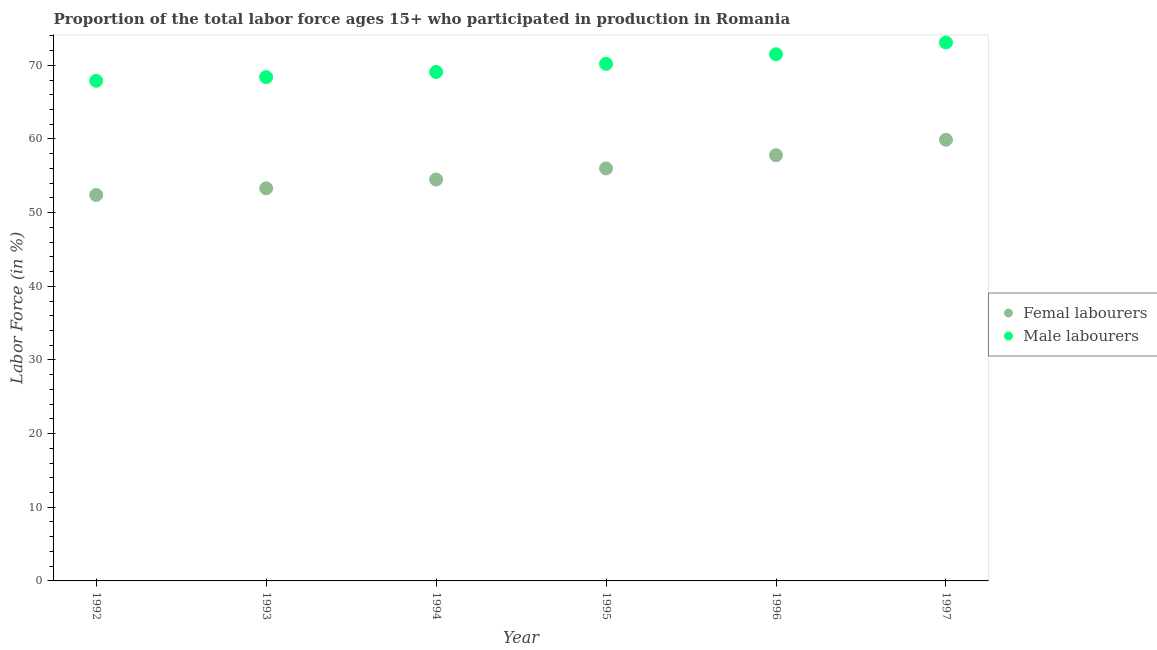What is the percentage of male labour force in 1992?
Your answer should be very brief. 67.9. Across all years, what is the maximum percentage of female labor force?
Your answer should be compact. 59.9. Across all years, what is the minimum percentage of male labour force?
Your answer should be very brief. 67.9. In which year was the percentage of male labour force maximum?
Provide a succinct answer. 1997. What is the total percentage of male labour force in the graph?
Offer a terse response. 420.2. What is the difference between the percentage of female labor force in 1996 and that in 1997?
Offer a terse response. -2.1. What is the difference between the percentage of male labour force in 1997 and the percentage of female labor force in 1993?
Offer a terse response. 19.8. What is the average percentage of female labor force per year?
Your answer should be very brief. 55.65. In the year 1996, what is the difference between the percentage of female labor force and percentage of male labour force?
Offer a very short reply. -13.7. What is the ratio of the percentage of male labour force in 1995 to that in 1996?
Your answer should be very brief. 0.98. What is the difference between the highest and the second highest percentage of female labor force?
Your response must be concise. 2.1. What is the difference between the highest and the lowest percentage of male labour force?
Your answer should be very brief. 5.2. In how many years, is the percentage of female labor force greater than the average percentage of female labor force taken over all years?
Ensure brevity in your answer.  3. Does the percentage of female labor force monotonically increase over the years?
Ensure brevity in your answer.  Yes. Is the percentage of male labour force strictly greater than the percentage of female labor force over the years?
Offer a terse response. Yes. Is the percentage of female labor force strictly less than the percentage of male labour force over the years?
Provide a short and direct response. Yes. What is the difference between two consecutive major ticks on the Y-axis?
Provide a succinct answer. 10. Does the graph contain any zero values?
Keep it short and to the point. No. Does the graph contain grids?
Give a very brief answer. No. Where does the legend appear in the graph?
Offer a terse response. Center right. How many legend labels are there?
Your answer should be very brief. 2. How are the legend labels stacked?
Make the answer very short. Vertical. What is the title of the graph?
Your answer should be very brief. Proportion of the total labor force ages 15+ who participated in production in Romania. What is the Labor Force (in %) in Femal labourers in 1992?
Your response must be concise. 52.4. What is the Labor Force (in %) of Male labourers in 1992?
Your answer should be very brief. 67.9. What is the Labor Force (in %) of Femal labourers in 1993?
Your answer should be compact. 53.3. What is the Labor Force (in %) in Male labourers in 1993?
Ensure brevity in your answer.  68.4. What is the Labor Force (in %) in Femal labourers in 1994?
Offer a very short reply. 54.5. What is the Labor Force (in %) of Male labourers in 1994?
Offer a very short reply. 69.1. What is the Labor Force (in %) in Male labourers in 1995?
Your answer should be compact. 70.2. What is the Labor Force (in %) of Femal labourers in 1996?
Your answer should be very brief. 57.8. What is the Labor Force (in %) of Male labourers in 1996?
Your answer should be very brief. 71.5. What is the Labor Force (in %) in Femal labourers in 1997?
Your answer should be very brief. 59.9. What is the Labor Force (in %) in Male labourers in 1997?
Your answer should be compact. 73.1. Across all years, what is the maximum Labor Force (in %) in Femal labourers?
Your response must be concise. 59.9. Across all years, what is the maximum Labor Force (in %) of Male labourers?
Your response must be concise. 73.1. Across all years, what is the minimum Labor Force (in %) in Femal labourers?
Give a very brief answer. 52.4. Across all years, what is the minimum Labor Force (in %) of Male labourers?
Offer a terse response. 67.9. What is the total Labor Force (in %) in Femal labourers in the graph?
Provide a succinct answer. 333.9. What is the total Labor Force (in %) in Male labourers in the graph?
Ensure brevity in your answer.  420.2. What is the difference between the Labor Force (in %) of Femal labourers in 1992 and that in 1993?
Provide a short and direct response. -0.9. What is the difference between the Labor Force (in %) of Male labourers in 1992 and that in 1994?
Your answer should be very brief. -1.2. What is the difference between the Labor Force (in %) in Femal labourers in 1992 and that in 1996?
Give a very brief answer. -5.4. What is the difference between the Labor Force (in %) of Male labourers in 1992 and that in 1996?
Provide a short and direct response. -3.6. What is the difference between the Labor Force (in %) of Male labourers in 1992 and that in 1997?
Provide a succinct answer. -5.2. What is the difference between the Labor Force (in %) in Femal labourers in 1993 and that in 1994?
Keep it short and to the point. -1.2. What is the difference between the Labor Force (in %) of Male labourers in 1993 and that in 1994?
Provide a short and direct response. -0.7. What is the difference between the Labor Force (in %) in Femal labourers in 1993 and that in 1995?
Provide a short and direct response. -2.7. What is the difference between the Labor Force (in %) in Male labourers in 1993 and that in 1995?
Provide a short and direct response. -1.8. What is the difference between the Labor Force (in %) in Femal labourers in 1993 and that in 1996?
Your answer should be very brief. -4.5. What is the difference between the Labor Force (in %) of Femal labourers in 1994 and that in 1995?
Provide a succinct answer. -1.5. What is the difference between the Labor Force (in %) in Male labourers in 1994 and that in 1995?
Your answer should be very brief. -1.1. What is the difference between the Labor Force (in %) of Male labourers in 1994 and that in 1997?
Your answer should be very brief. -4. What is the difference between the Labor Force (in %) of Male labourers in 1995 and that in 1996?
Offer a very short reply. -1.3. What is the difference between the Labor Force (in %) of Femal labourers in 1995 and that in 1997?
Keep it short and to the point. -3.9. What is the difference between the Labor Force (in %) of Femal labourers in 1992 and the Labor Force (in %) of Male labourers in 1994?
Ensure brevity in your answer.  -16.7. What is the difference between the Labor Force (in %) of Femal labourers in 1992 and the Labor Force (in %) of Male labourers in 1995?
Ensure brevity in your answer.  -17.8. What is the difference between the Labor Force (in %) in Femal labourers in 1992 and the Labor Force (in %) in Male labourers in 1996?
Your answer should be compact. -19.1. What is the difference between the Labor Force (in %) in Femal labourers in 1992 and the Labor Force (in %) in Male labourers in 1997?
Provide a short and direct response. -20.7. What is the difference between the Labor Force (in %) of Femal labourers in 1993 and the Labor Force (in %) of Male labourers in 1994?
Your answer should be very brief. -15.8. What is the difference between the Labor Force (in %) in Femal labourers in 1993 and the Labor Force (in %) in Male labourers in 1995?
Offer a very short reply. -16.9. What is the difference between the Labor Force (in %) of Femal labourers in 1993 and the Labor Force (in %) of Male labourers in 1996?
Your answer should be very brief. -18.2. What is the difference between the Labor Force (in %) of Femal labourers in 1993 and the Labor Force (in %) of Male labourers in 1997?
Ensure brevity in your answer.  -19.8. What is the difference between the Labor Force (in %) of Femal labourers in 1994 and the Labor Force (in %) of Male labourers in 1995?
Your answer should be compact. -15.7. What is the difference between the Labor Force (in %) in Femal labourers in 1994 and the Labor Force (in %) in Male labourers in 1996?
Provide a succinct answer. -17. What is the difference between the Labor Force (in %) of Femal labourers in 1994 and the Labor Force (in %) of Male labourers in 1997?
Provide a short and direct response. -18.6. What is the difference between the Labor Force (in %) in Femal labourers in 1995 and the Labor Force (in %) in Male labourers in 1996?
Your response must be concise. -15.5. What is the difference between the Labor Force (in %) in Femal labourers in 1995 and the Labor Force (in %) in Male labourers in 1997?
Give a very brief answer. -17.1. What is the difference between the Labor Force (in %) in Femal labourers in 1996 and the Labor Force (in %) in Male labourers in 1997?
Provide a succinct answer. -15.3. What is the average Labor Force (in %) of Femal labourers per year?
Ensure brevity in your answer.  55.65. What is the average Labor Force (in %) in Male labourers per year?
Your answer should be very brief. 70.03. In the year 1992, what is the difference between the Labor Force (in %) of Femal labourers and Labor Force (in %) of Male labourers?
Provide a short and direct response. -15.5. In the year 1993, what is the difference between the Labor Force (in %) in Femal labourers and Labor Force (in %) in Male labourers?
Your response must be concise. -15.1. In the year 1994, what is the difference between the Labor Force (in %) in Femal labourers and Labor Force (in %) in Male labourers?
Ensure brevity in your answer.  -14.6. In the year 1996, what is the difference between the Labor Force (in %) in Femal labourers and Labor Force (in %) in Male labourers?
Offer a very short reply. -13.7. What is the ratio of the Labor Force (in %) of Femal labourers in 1992 to that in 1993?
Make the answer very short. 0.98. What is the ratio of the Labor Force (in %) in Male labourers in 1992 to that in 1993?
Your answer should be compact. 0.99. What is the ratio of the Labor Force (in %) in Femal labourers in 1992 to that in 1994?
Your answer should be very brief. 0.96. What is the ratio of the Labor Force (in %) in Male labourers in 1992 to that in 1994?
Provide a succinct answer. 0.98. What is the ratio of the Labor Force (in %) in Femal labourers in 1992 to that in 1995?
Keep it short and to the point. 0.94. What is the ratio of the Labor Force (in %) in Male labourers in 1992 to that in 1995?
Ensure brevity in your answer.  0.97. What is the ratio of the Labor Force (in %) of Femal labourers in 1992 to that in 1996?
Your answer should be very brief. 0.91. What is the ratio of the Labor Force (in %) in Male labourers in 1992 to that in 1996?
Offer a terse response. 0.95. What is the ratio of the Labor Force (in %) of Femal labourers in 1992 to that in 1997?
Provide a short and direct response. 0.87. What is the ratio of the Labor Force (in %) in Male labourers in 1992 to that in 1997?
Provide a succinct answer. 0.93. What is the ratio of the Labor Force (in %) of Femal labourers in 1993 to that in 1994?
Your response must be concise. 0.98. What is the ratio of the Labor Force (in %) of Femal labourers in 1993 to that in 1995?
Keep it short and to the point. 0.95. What is the ratio of the Labor Force (in %) in Male labourers in 1993 to that in 1995?
Offer a terse response. 0.97. What is the ratio of the Labor Force (in %) in Femal labourers in 1993 to that in 1996?
Provide a succinct answer. 0.92. What is the ratio of the Labor Force (in %) in Male labourers in 1993 to that in 1996?
Provide a succinct answer. 0.96. What is the ratio of the Labor Force (in %) in Femal labourers in 1993 to that in 1997?
Offer a terse response. 0.89. What is the ratio of the Labor Force (in %) of Male labourers in 1993 to that in 1997?
Offer a terse response. 0.94. What is the ratio of the Labor Force (in %) of Femal labourers in 1994 to that in 1995?
Offer a very short reply. 0.97. What is the ratio of the Labor Force (in %) in Male labourers in 1994 to that in 1995?
Ensure brevity in your answer.  0.98. What is the ratio of the Labor Force (in %) of Femal labourers in 1994 to that in 1996?
Your response must be concise. 0.94. What is the ratio of the Labor Force (in %) in Male labourers in 1994 to that in 1996?
Your response must be concise. 0.97. What is the ratio of the Labor Force (in %) in Femal labourers in 1994 to that in 1997?
Ensure brevity in your answer.  0.91. What is the ratio of the Labor Force (in %) of Male labourers in 1994 to that in 1997?
Your response must be concise. 0.95. What is the ratio of the Labor Force (in %) in Femal labourers in 1995 to that in 1996?
Offer a terse response. 0.97. What is the ratio of the Labor Force (in %) in Male labourers in 1995 to that in 1996?
Your answer should be compact. 0.98. What is the ratio of the Labor Force (in %) in Femal labourers in 1995 to that in 1997?
Give a very brief answer. 0.93. What is the ratio of the Labor Force (in %) of Male labourers in 1995 to that in 1997?
Your answer should be very brief. 0.96. What is the ratio of the Labor Force (in %) in Femal labourers in 1996 to that in 1997?
Your answer should be compact. 0.96. What is the ratio of the Labor Force (in %) of Male labourers in 1996 to that in 1997?
Offer a very short reply. 0.98. What is the difference between the highest and the second highest Labor Force (in %) of Femal labourers?
Your answer should be very brief. 2.1. What is the difference between the highest and the lowest Labor Force (in %) in Male labourers?
Your answer should be very brief. 5.2. 